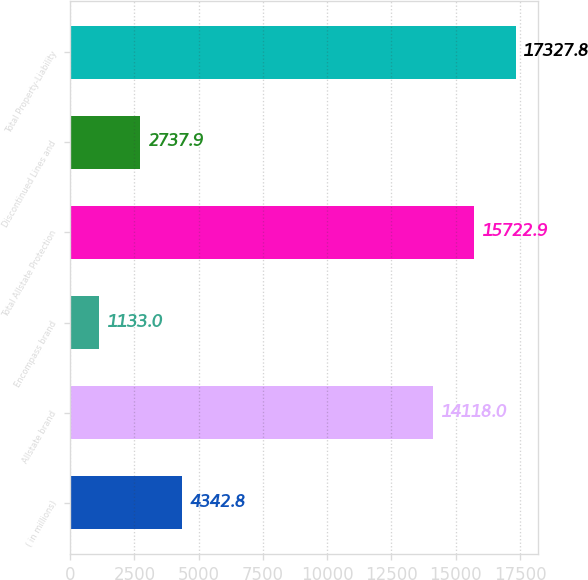Convert chart to OTSL. <chart><loc_0><loc_0><loc_500><loc_500><bar_chart><fcel>( in millions)<fcel>Allstate brand<fcel>Encompass brand<fcel>Total Allstate Protection<fcel>Discontinued Lines and<fcel>Total Property-Liability<nl><fcel>4342.8<fcel>14118<fcel>1133<fcel>15722.9<fcel>2737.9<fcel>17327.8<nl></chart> 